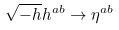<formula> <loc_0><loc_0><loc_500><loc_500>\sqrt { - h } h ^ { a b } \rightarrow \eta ^ { a b }</formula> 